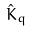<formula> <loc_0><loc_0><loc_500><loc_500>\hat { K } _ { q }</formula> 